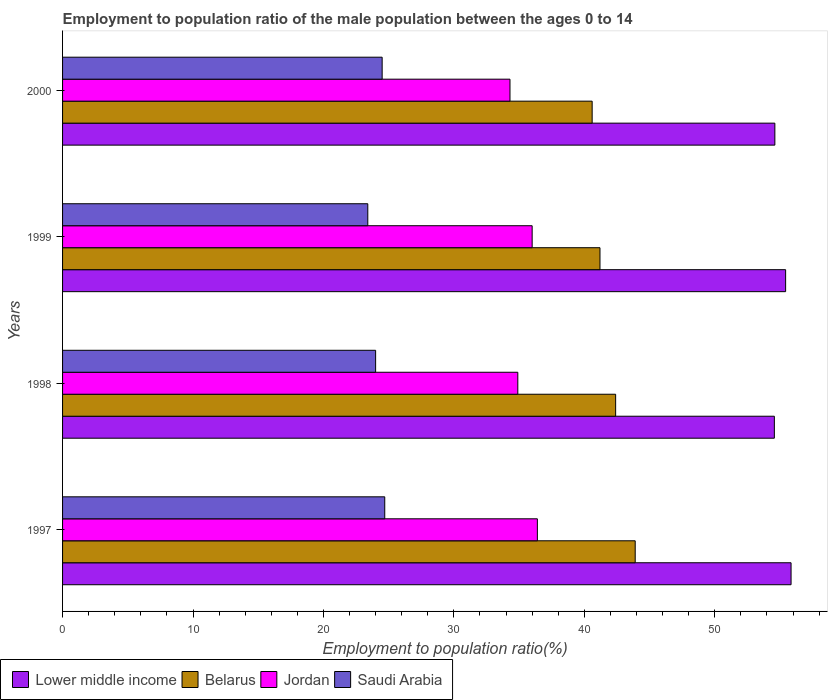How many different coloured bars are there?
Make the answer very short. 4. How many groups of bars are there?
Keep it short and to the point. 4. Are the number of bars on each tick of the Y-axis equal?
Offer a terse response. Yes. How many bars are there on the 3rd tick from the top?
Your response must be concise. 4. What is the label of the 2nd group of bars from the top?
Provide a succinct answer. 1999. In how many cases, is the number of bars for a given year not equal to the number of legend labels?
Your response must be concise. 0. What is the employment to population ratio in Lower middle income in 1999?
Give a very brief answer. 55.43. Across all years, what is the maximum employment to population ratio in Lower middle income?
Your answer should be very brief. 55.85. Across all years, what is the minimum employment to population ratio in Belarus?
Your answer should be compact. 40.6. In which year was the employment to population ratio in Lower middle income minimum?
Make the answer very short. 1998. What is the total employment to population ratio in Lower middle income in the graph?
Provide a short and direct response. 220.46. What is the difference between the employment to population ratio in Belarus in 1998 and that in 1999?
Offer a terse response. 1.2. What is the difference between the employment to population ratio in Saudi Arabia in 1997 and the employment to population ratio in Jordan in 1999?
Offer a terse response. -11.3. What is the average employment to population ratio in Jordan per year?
Offer a terse response. 35.4. In the year 1999, what is the difference between the employment to population ratio in Jordan and employment to population ratio in Lower middle income?
Make the answer very short. -19.43. In how many years, is the employment to population ratio in Belarus greater than 36 %?
Your response must be concise. 4. What is the ratio of the employment to population ratio in Jordan in 1997 to that in 1999?
Your answer should be very brief. 1.01. What is the difference between the highest and the second highest employment to population ratio in Jordan?
Offer a terse response. 0.4. What is the difference between the highest and the lowest employment to population ratio in Saudi Arabia?
Ensure brevity in your answer.  1.3. Is the sum of the employment to population ratio in Belarus in 1997 and 1998 greater than the maximum employment to population ratio in Lower middle income across all years?
Ensure brevity in your answer.  Yes. Is it the case that in every year, the sum of the employment to population ratio in Saudi Arabia and employment to population ratio in Lower middle income is greater than the sum of employment to population ratio in Belarus and employment to population ratio in Jordan?
Keep it short and to the point. No. What does the 2nd bar from the top in 2000 represents?
Provide a short and direct response. Jordan. What does the 1st bar from the bottom in 1998 represents?
Give a very brief answer. Lower middle income. Is it the case that in every year, the sum of the employment to population ratio in Lower middle income and employment to population ratio in Jordan is greater than the employment to population ratio in Belarus?
Offer a very short reply. Yes. How many bars are there?
Your response must be concise. 16. How many years are there in the graph?
Provide a short and direct response. 4. Does the graph contain any zero values?
Offer a very short reply. No. What is the title of the graph?
Make the answer very short. Employment to population ratio of the male population between the ages 0 to 14. Does "Slovak Republic" appear as one of the legend labels in the graph?
Offer a very short reply. No. What is the label or title of the X-axis?
Ensure brevity in your answer.  Employment to population ratio(%). What is the label or title of the Y-axis?
Your answer should be compact. Years. What is the Employment to population ratio(%) of Lower middle income in 1997?
Offer a terse response. 55.85. What is the Employment to population ratio(%) of Belarus in 1997?
Your answer should be very brief. 43.9. What is the Employment to population ratio(%) in Jordan in 1997?
Ensure brevity in your answer.  36.4. What is the Employment to population ratio(%) of Saudi Arabia in 1997?
Give a very brief answer. 24.7. What is the Employment to population ratio(%) of Lower middle income in 1998?
Ensure brevity in your answer.  54.57. What is the Employment to population ratio(%) of Belarus in 1998?
Your response must be concise. 42.4. What is the Employment to population ratio(%) of Jordan in 1998?
Ensure brevity in your answer.  34.9. What is the Employment to population ratio(%) of Lower middle income in 1999?
Offer a terse response. 55.43. What is the Employment to population ratio(%) in Belarus in 1999?
Offer a terse response. 41.2. What is the Employment to population ratio(%) in Jordan in 1999?
Your response must be concise. 36. What is the Employment to population ratio(%) in Saudi Arabia in 1999?
Your response must be concise. 23.4. What is the Employment to population ratio(%) in Lower middle income in 2000?
Provide a short and direct response. 54.61. What is the Employment to population ratio(%) in Belarus in 2000?
Provide a short and direct response. 40.6. What is the Employment to population ratio(%) of Jordan in 2000?
Offer a terse response. 34.3. What is the Employment to population ratio(%) of Saudi Arabia in 2000?
Your answer should be compact. 24.5. Across all years, what is the maximum Employment to population ratio(%) of Lower middle income?
Provide a succinct answer. 55.85. Across all years, what is the maximum Employment to population ratio(%) of Belarus?
Provide a succinct answer. 43.9. Across all years, what is the maximum Employment to population ratio(%) in Jordan?
Offer a terse response. 36.4. Across all years, what is the maximum Employment to population ratio(%) of Saudi Arabia?
Your answer should be very brief. 24.7. Across all years, what is the minimum Employment to population ratio(%) in Lower middle income?
Make the answer very short. 54.57. Across all years, what is the minimum Employment to population ratio(%) in Belarus?
Your answer should be compact. 40.6. Across all years, what is the minimum Employment to population ratio(%) of Jordan?
Provide a succinct answer. 34.3. Across all years, what is the minimum Employment to population ratio(%) of Saudi Arabia?
Make the answer very short. 23.4. What is the total Employment to population ratio(%) in Lower middle income in the graph?
Make the answer very short. 220.46. What is the total Employment to population ratio(%) of Belarus in the graph?
Keep it short and to the point. 168.1. What is the total Employment to population ratio(%) in Jordan in the graph?
Your answer should be very brief. 141.6. What is the total Employment to population ratio(%) in Saudi Arabia in the graph?
Keep it short and to the point. 96.6. What is the difference between the Employment to population ratio(%) of Lower middle income in 1997 and that in 1998?
Your answer should be compact. 1.28. What is the difference between the Employment to population ratio(%) of Belarus in 1997 and that in 1998?
Offer a terse response. 1.5. What is the difference between the Employment to population ratio(%) in Lower middle income in 1997 and that in 1999?
Ensure brevity in your answer.  0.42. What is the difference between the Employment to population ratio(%) of Jordan in 1997 and that in 1999?
Make the answer very short. 0.4. What is the difference between the Employment to population ratio(%) in Lower middle income in 1997 and that in 2000?
Make the answer very short. 1.24. What is the difference between the Employment to population ratio(%) of Jordan in 1997 and that in 2000?
Your answer should be compact. 2.1. What is the difference between the Employment to population ratio(%) of Saudi Arabia in 1997 and that in 2000?
Keep it short and to the point. 0.2. What is the difference between the Employment to population ratio(%) in Lower middle income in 1998 and that in 1999?
Offer a very short reply. -0.86. What is the difference between the Employment to population ratio(%) in Belarus in 1998 and that in 1999?
Offer a terse response. 1.2. What is the difference between the Employment to population ratio(%) of Jordan in 1998 and that in 1999?
Your answer should be very brief. -1.1. What is the difference between the Employment to population ratio(%) in Lower middle income in 1998 and that in 2000?
Make the answer very short. -0.04. What is the difference between the Employment to population ratio(%) of Saudi Arabia in 1998 and that in 2000?
Your response must be concise. -0.5. What is the difference between the Employment to population ratio(%) of Lower middle income in 1999 and that in 2000?
Provide a succinct answer. 0.83. What is the difference between the Employment to population ratio(%) in Saudi Arabia in 1999 and that in 2000?
Provide a succinct answer. -1.1. What is the difference between the Employment to population ratio(%) in Lower middle income in 1997 and the Employment to population ratio(%) in Belarus in 1998?
Offer a terse response. 13.45. What is the difference between the Employment to population ratio(%) of Lower middle income in 1997 and the Employment to population ratio(%) of Jordan in 1998?
Offer a terse response. 20.95. What is the difference between the Employment to population ratio(%) of Lower middle income in 1997 and the Employment to population ratio(%) of Saudi Arabia in 1998?
Ensure brevity in your answer.  31.85. What is the difference between the Employment to population ratio(%) in Belarus in 1997 and the Employment to population ratio(%) in Saudi Arabia in 1998?
Provide a succinct answer. 19.9. What is the difference between the Employment to population ratio(%) of Lower middle income in 1997 and the Employment to population ratio(%) of Belarus in 1999?
Ensure brevity in your answer.  14.65. What is the difference between the Employment to population ratio(%) in Lower middle income in 1997 and the Employment to population ratio(%) in Jordan in 1999?
Provide a short and direct response. 19.85. What is the difference between the Employment to population ratio(%) in Lower middle income in 1997 and the Employment to population ratio(%) in Saudi Arabia in 1999?
Your answer should be very brief. 32.45. What is the difference between the Employment to population ratio(%) of Belarus in 1997 and the Employment to population ratio(%) of Jordan in 1999?
Your answer should be very brief. 7.9. What is the difference between the Employment to population ratio(%) in Belarus in 1997 and the Employment to population ratio(%) in Saudi Arabia in 1999?
Make the answer very short. 20.5. What is the difference between the Employment to population ratio(%) of Jordan in 1997 and the Employment to population ratio(%) of Saudi Arabia in 1999?
Provide a short and direct response. 13. What is the difference between the Employment to population ratio(%) of Lower middle income in 1997 and the Employment to population ratio(%) of Belarus in 2000?
Offer a very short reply. 15.25. What is the difference between the Employment to population ratio(%) in Lower middle income in 1997 and the Employment to population ratio(%) in Jordan in 2000?
Keep it short and to the point. 21.55. What is the difference between the Employment to population ratio(%) in Lower middle income in 1997 and the Employment to population ratio(%) in Saudi Arabia in 2000?
Keep it short and to the point. 31.35. What is the difference between the Employment to population ratio(%) of Belarus in 1997 and the Employment to population ratio(%) of Jordan in 2000?
Offer a very short reply. 9.6. What is the difference between the Employment to population ratio(%) in Belarus in 1997 and the Employment to population ratio(%) in Saudi Arabia in 2000?
Make the answer very short. 19.4. What is the difference between the Employment to population ratio(%) of Lower middle income in 1998 and the Employment to population ratio(%) of Belarus in 1999?
Your answer should be very brief. 13.37. What is the difference between the Employment to population ratio(%) in Lower middle income in 1998 and the Employment to population ratio(%) in Jordan in 1999?
Provide a short and direct response. 18.57. What is the difference between the Employment to population ratio(%) of Lower middle income in 1998 and the Employment to population ratio(%) of Saudi Arabia in 1999?
Make the answer very short. 31.17. What is the difference between the Employment to population ratio(%) in Belarus in 1998 and the Employment to population ratio(%) in Jordan in 1999?
Make the answer very short. 6.4. What is the difference between the Employment to population ratio(%) in Belarus in 1998 and the Employment to population ratio(%) in Saudi Arabia in 1999?
Offer a terse response. 19. What is the difference between the Employment to population ratio(%) in Jordan in 1998 and the Employment to population ratio(%) in Saudi Arabia in 1999?
Make the answer very short. 11.5. What is the difference between the Employment to population ratio(%) of Lower middle income in 1998 and the Employment to population ratio(%) of Belarus in 2000?
Offer a terse response. 13.97. What is the difference between the Employment to population ratio(%) in Lower middle income in 1998 and the Employment to population ratio(%) in Jordan in 2000?
Make the answer very short. 20.27. What is the difference between the Employment to population ratio(%) in Lower middle income in 1998 and the Employment to population ratio(%) in Saudi Arabia in 2000?
Keep it short and to the point. 30.07. What is the difference between the Employment to population ratio(%) of Belarus in 1998 and the Employment to population ratio(%) of Saudi Arabia in 2000?
Offer a terse response. 17.9. What is the difference between the Employment to population ratio(%) of Lower middle income in 1999 and the Employment to population ratio(%) of Belarus in 2000?
Your answer should be very brief. 14.83. What is the difference between the Employment to population ratio(%) of Lower middle income in 1999 and the Employment to population ratio(%) of Jordan in 2000?
Offer a very short reply. 21.13. What is the difference between the Employment to population ratio(%) in Lower middle income in 1999 and the Employment to population ratio(%) in Saudi Arabia in 2000?
Provide a succinct answer. 30.93. What is the average Employment to population ratio(%) of Lower middle income per year?
Your answer should be compact. 55.11. What is the average Employment to population ratio(%) of Belarus per year?
Keep it short and to the point. 42.02. What is the average Employment to population ratio(%) of Jordan per year?
Provide a short and direct response. 35.4. What is the average Employment to population ratio(%) of Saudi Arabia per year?
Provide a succinct answer. 24.15. In the year 1997, what is the difference between the Employment to population ratio(%) in Lower middle income and Employment to population ratio(%) in Belarus?
Ensure brevity in your answer.  11.95. In the year 1997, what is the difference between the Employment to population ratio(%) in Lower middle income and Employment to population ratio(%) in Jordan?
Provide a short and direct response. 19.45. In the year 1997, what is the difference between the Employment to population ratio(%) in Lower middle income and Employment to population ratio(%) in Saudi Arabia?
Give a very brief answer. 31.15. In the year 1997, what is the difference between the Employment to population ratio(%) in Belarus and Employment to population ratio(%) in Saudi Arabia?
Make the answer very short. 19.2. In the year 1998, what is the difference between the Employment to population ratio(%) in Lower middle income and Employment to population ratio(%) in Belarus?
Offer a very short reply. 12.17. In the year 1998, what is the difference between the Employment to population ratio(%) in Lower middle income and Employment to population ratio(%) in Jordan?
Make the answer very short. 19.67. In the year 1998, what is the difference between the Employment to population ratio(%) in Lower middle income and Employment to population ratio(%) in Saudi Arabia?
Offer a terse response. 30.57. In the year 1998, what is the difference between the Employment to population ratio(%) in Belarus and Employment to population ratio(%) in Saudi Arabia?
Make the answer very short. 18.4. In the year 1999, what is the difference between the Employment to population ratio(%) of Lower middle income and Employment to population ratio(%) of Belarus?
Offer a terse response. 14.23. In the year 1999, what is the difference between the Employment to population ratio(%) in Lower middle income and Employment to population ratio(%) in Jordan?
Ensure brevity in your answer.  19.43. In the year 1999, what is the difference between the Employment to population ratio(%) in Lower middle income and Employment to population ratio(%) in Saudi Arabia?
Offer a terse response. 32.03. In the year 1999, what is the difference between the Employment to population ratio(%) in Belarus and Employment to population ratio(%) in Saudi Arabia?
Your answer should be compact. 17.8. In the year 1999, what is the difference between the Employment to population ratio(%) in Jordan and Employment to population ratio(%) in Saudi Arabia?
Provide a short and direct response. 12.6. In the year 2000, what is the difference between the Employment to population ratio(%) in Lower middle income and Employment to population ratio(%) in Belarus?
Give a very brief answer. 14.01. In the year 2000, what is the difference between the Employment to population ratio(%) in Lower middle income and Employment to population ratio(%) in Jordan?
Make the answer very short. 20.31. In the year 2000, what is the difference between the Employment to population ratio(%) of Lower middle income and Employment to population ratio(%) of Saudi Arabia?
Offer a terse response. 30.11. In the year 2000, what is the difference between the Employment to population ratio(%) of Belarus and Employment to population ratio(%) of Jordan?
Provide a short and direct response. 6.3. In the year 2000, what is the difference between the Employment to population ratio(%) of Belarus and Employment to population ratio(%) of Saudi Arabia?
Provide a succinct answer. 16.1. In the year 2000, what is the difference between the Employment to population ratio(%) of Jordan and Employment to population ratio(%) of Saudi Arabia?
Provide a short and direct response. 9.8. What is the ratio of the Employment to population ratio(%) of Lower middle income in 1997 to that in 1998?
Ensure brevity in your answer.  1.02. What is the ratio of the Employment to population ratio(%) of Belarus in 1997 to that in 1998?
Provide a short and direct response. 1.04. What is the ratio of the Employment to population ratio(%) in Jordan in 1997 to that in 1998?
Your response must be concise. 1.04. What is the ratio of the Employment to population ratio(%) of Saudi Arabia in 1997 to that in 1998?
Provide a short and direct response. 1.03. What is the ratio of the Employment to population ratio(%) of Lower middle income in 1997 to that in 1999?
Offer a terse response. 1.01. What is the ratio of the Employment to population ratio(%) in Belarus in 1997 to that in 1999?
Your answer should be very brief. 1.07. What is the ratio of the Employment to population ratio(%) in Jordan in 1997 to that in 1999?
Make the answer very short. 1.01. What is the ratio of the Employment to population ratio(%) of Saudi Arabia in 1997 to that in 1999?
Provide a succinct answer. 1.06. What is the ratio of the Employment to population ratio(%) of Lower middle income in 1997 to that in 2000?
Ensure brevity in your answer.  1.02. What is the ratio of the Employment to population ratio(%) in Belarus in 1997 to that in 2000?
Make the answer very short. 1.08. What is the ratio of the Employment to population ratio(%) of Jordan in 1997 to that in 2000?
Provide a succinct answer. 1.06. What is the ratio of the Employment to population ratio(%) of Saudi Arabia in 1997 to that in 2000?
Keep it short and to the point. 1.01. What is the ratio of the Employment to population ratio(%) in Lower middle income in 1998 to that in 1999?
Your response must be concise. 0.98. What is the ratio of the Employment to population ratio(%) in Belarus in 1998 to that in 1999?
Provide a succinct answer. 1.03. What is the ratio of the Employment to population ratio(%) of Jordan in 1998 to that in 1999?
Your response must be concise. 0.97. What is the ratio of the Employment to population ratio(%) of Saudi Arabia in 1998 to that in 1999?
Ensure brevity in your answer.  1.03. What is the ratio of the Employment to population ratio(%) in Belarus in 1998 to that in 2000?
Your response must be concise. 1.04. What is the ratio of the Employment to population ratio(%) of Jordan in 1998 to that in 2000?
Give a very brief answer. 1.02. What is the ratio of the Employment to population ratio(%) in Saudi Arabia in 1998 to that in 2000?
Your answer should be compact. 0.98. What is the ratio of the Employment to population ratio(%) of Lower middle income in 1999 to that in 2000?
Offer a terse response. 1.02. What is the ratio of the Employment to population ratio(%) of Belarus in 1999 to that in 2000?
Provide a succinct answer. 1.01. What is the ratio of the Employment to population ratio(%) in Jordan in 1999 to that in 2000?
Ensure brevity in your answer.  1.05. What is the ratio of the Employment to population ratio(%) of Saudi Arabia in 1999 to that in 2000?
Your response must be concise. 0.96. What is the difference between the highest and the second highest Employment to population ratio(%) in Lower middle income?
Offer a very short reply. 0.42. What is the difference between the highest and the second highest Employment to population ratio(%) of Belarus?
Ensure brevity in your answer.  1.5. What is the difference between the highest and the second highest Employment to population ratio(%) in Jordan?
Keep it short and to the point. 0.4. What is the difference between the highest and the second highest Employment to population ratio(%) in Saudi Arabia?
Offer a very short reply. 0.2. What is the difference between the highest and the lowest Employment to population ratio(%) in Lower middle income?
Your response must be concise. 1.28. What is the difference between the highest and the lowest Employment to population ratio(%) in Jordan?
Provide a short and direct response. 2.1. 